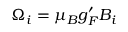Convert formula to latex. <formula><loc_0><loc_0><loc_500><loc_500>\Omega _ { i } = \mu _ { B } g _ { F } ^ { \prime } B _ { i }</formula> 